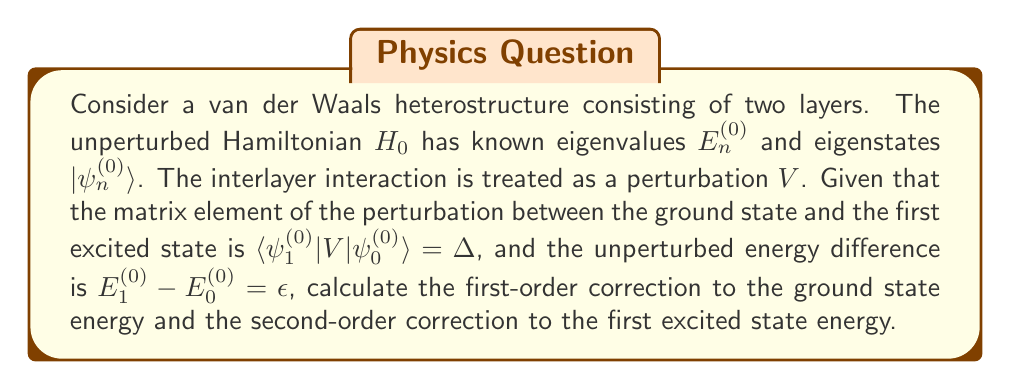What is the answer to this math problem? To solve this problem, we'll use time-independent perturbation theory.

1. First-order correction to the ground state energy:
The first-order correction to the energy of the ground state is given by:

$$E_0^{(1)} = \langle\psi_0^{(0)}|V|\psi_0^{(0)}\rangle$$

However, we are not given this matrix element directly. Since the perturbation is due to interlayer interaction, we can assume that the diagonal elements are zero. Therefore:

$$E_0^{(1)} = 0$$

2. Second-order correction to the first excited state energy:
The second-order correction to the energy of the first excited state is given by:

$$E_1^{(2)} = \sum_{n \neq 1} \frac{|\langle\psi_n^{(0)}|V|\psi_1^{(0)}\rangle|^2}{E_1^{(0)} - E_n^{(0)}}$$

We are only given information about the interaction between the ground state and the first excited state. Assuming this is the dominant contribution, we can approximate:

$$E_1^{(2)} \approx \frac{|\langle\psi_0^{(0)}|V|\psi_1^{(0)}\rangle|^2}{E_1^{(0)} - E_0^{(0)}}$$

We know that $\langle\psi_1^{(0)}|V|\psi_0^{(0)}\rangle = \Delta$. Due to the Hermiticity of the Hamiltonian, we can say:

$$\langle\psi_0^{(0)}|V|\psi_1^{(0)}\rangle = \langle\psi_1^{(0)}|V|\psi_0^{(0)}\rangle^* = \Delta^*$$

The energy difference $E_1^{(0)} - E_0^{(0)} = \epsilon$ is given.

Therefore, we can calculate:

$$E_1^{(2)} \approx \frac{|\Delta|^2}{\epsilon}$$
Answer: $E_0^{(1)} = 0$, $E_1^{(2)} \approx \frac{|\Delta|^2}{\epsilon}$ 